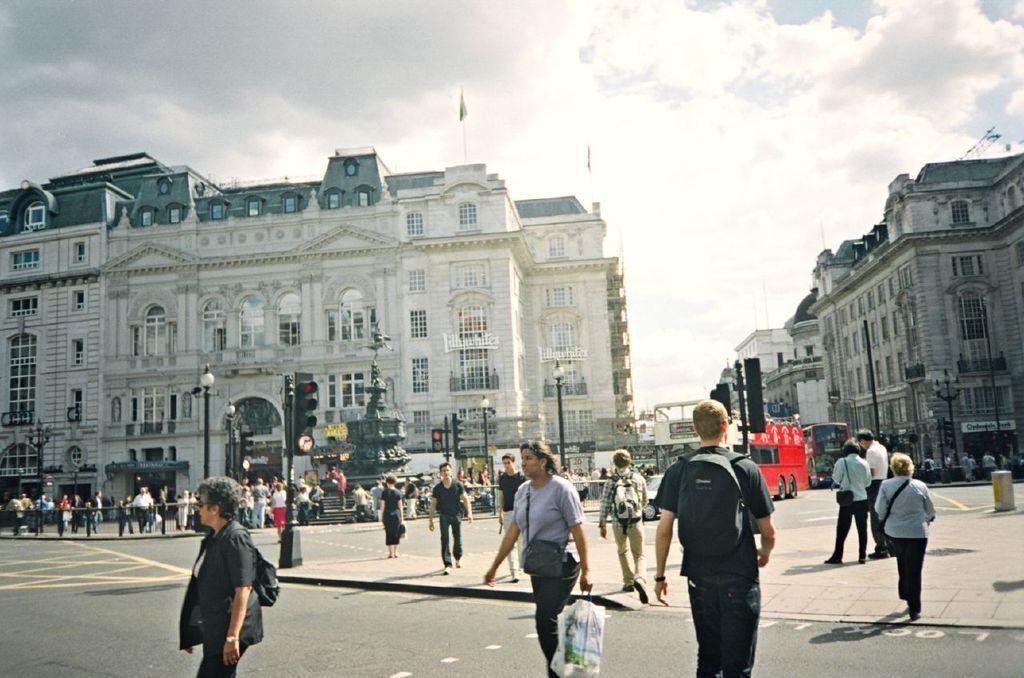Describe this image in one or two sentences. In this picture we can see a group of people walking on the road, buses, traffic signal light, poles and in the background we can see the sky with clouds. 